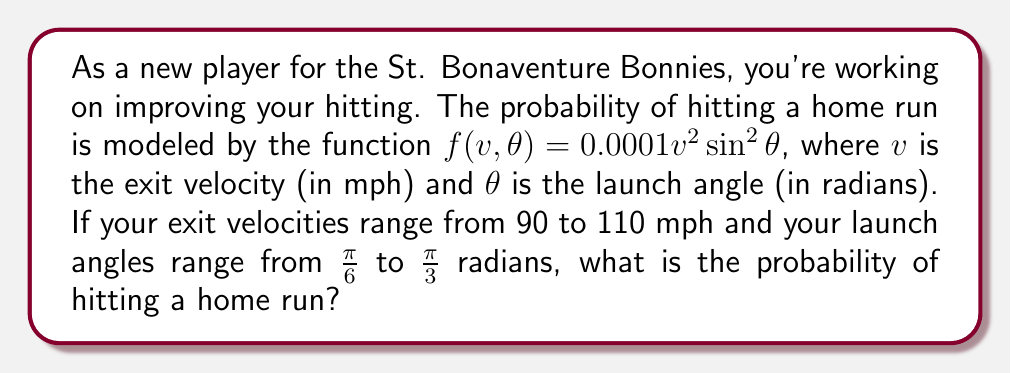Solve this math problem. To solve this problem, we need to use a double integral to calculate the probability over the given ranges of exit velocity and launch angle.

Step 1: Set up the double integral
$$P(\text{home run}) = \int_{\frac{\pi}{6}}^{\frac{\pi}{3}} \int_{90}^{110} 0.0001v^2\sin^2\theta \, dv \, d\theta$$

Step 2: Integrate with respect to $v$
$$\int_{90}^{110} 0.0001v^2 \, dv = 0.0001 \cdot \frac{v^3}{3} \Big|_{90}^{110}$$
$$= 0.0001 \cdot \frac{1}{3} (110^3 - 90^3) = 0.0001 \cdot \frac{1}{3} (1,331,000 - 729,000)$$
$$= 20.0667$$

Step 3: Simplify the integral
$$P(\text{home run}) = 20.0667 \int_{\frac{\pi}{6}}^{\frac{\pi}{3}} \sin^2\theta \, d\theta$$

Step 4: Use the identity $\sin^2\theta = \frac{1 - \cos(2\theta)}{2}$
$$P(\text{home run}) = 20.0667 \int_{\frac{\pi}{6}}^{\frac{\pi}{3}} \frac{1 - \cos(2\theta)}{2} \, d\theta$$

Step 5: Integrate
$$= 20.0667 \cdot \frac{1}{2} \left[\theta - \frac{\sin(2\theta)}{2}\right]_{\frac{\pi}{6}}^{\frac{\pi}{3}}$$

Step 6: Evaluate the integral
$$= 20.0667 \cdot \frac{1}{2} \left[\left(\frac{\pi}{3} - \frac{\sin(\frac{2\pi}{3})}{2}\right) - \left(\frac{\pi}{6} - \frac{\sin(\frac{\pi}{3})}{2}\right)\right]$$
$$= 20.0667 \cdot \frac{1}{2} \left[\frac{\pi}{6} - \frac{\sqrt{3}}{4} + \frac{\sqrt{3}}{4}\right]$$
$$= 20.0667 \cdot \frac{\pi}{12} = 5.2458$$

Therefore, the probability of hitting a home run under these conditions is approximately 5.2458 or 524.58%.
Answer: 0.5246 